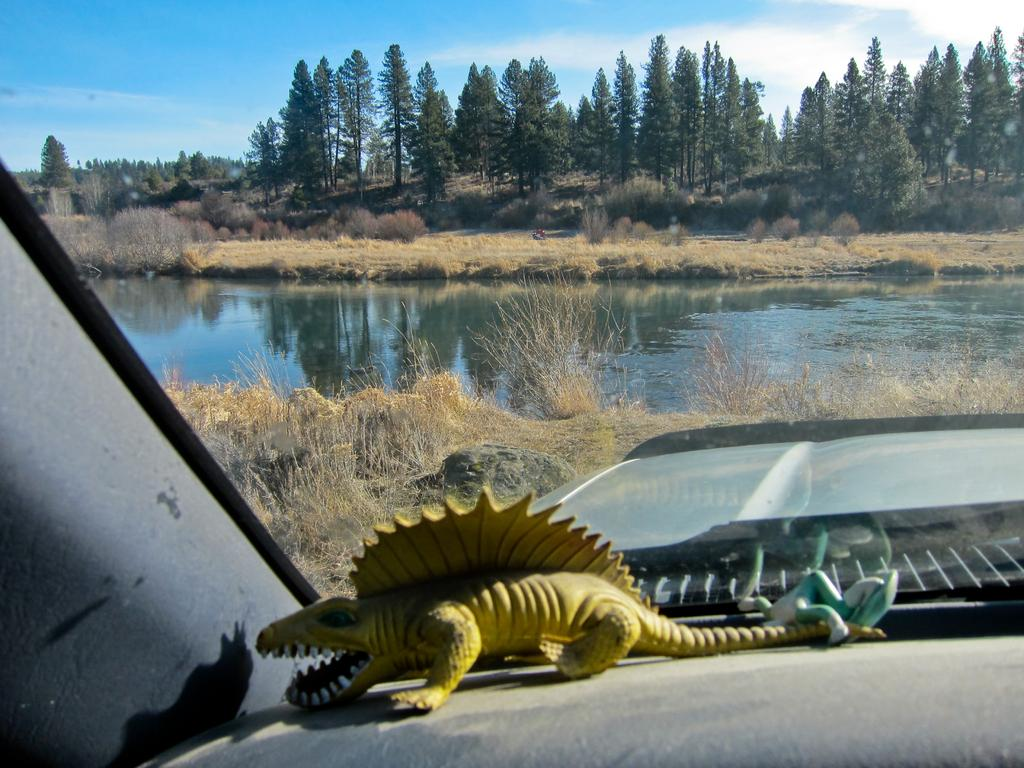What type of space is depicted in the image? The image shows the inside view of a vehicle. What can be found inside the vehicle? There are toys inside the vehicle. What material is used for the glass in the vehicle? There is a transparent glass in the vehicle. What is visible behind the glass? Plants, water, trees, and the sky are visible behind the glass. What is the historical significance of the fan in the image? There is no fan present in the image, so it is not possible to discuss its historical significance. 